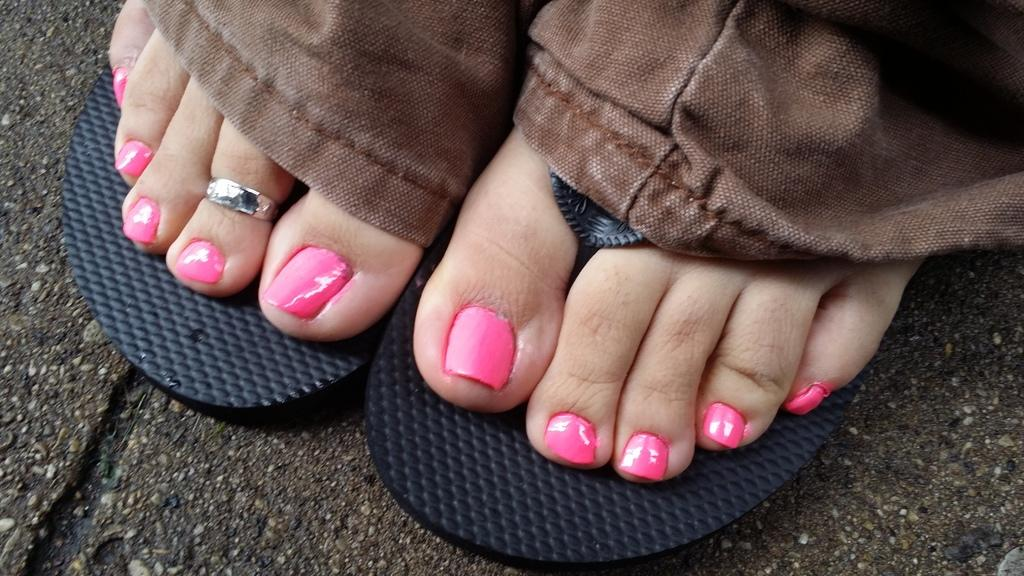What part of a person can be seen in the image? There are legs of a person visible in the image. What is covering the person's feet in the image? There is footwear visible in the image. What type of bean is being used as a lawyer in the image? There is no bean or lawyer present in the image. 